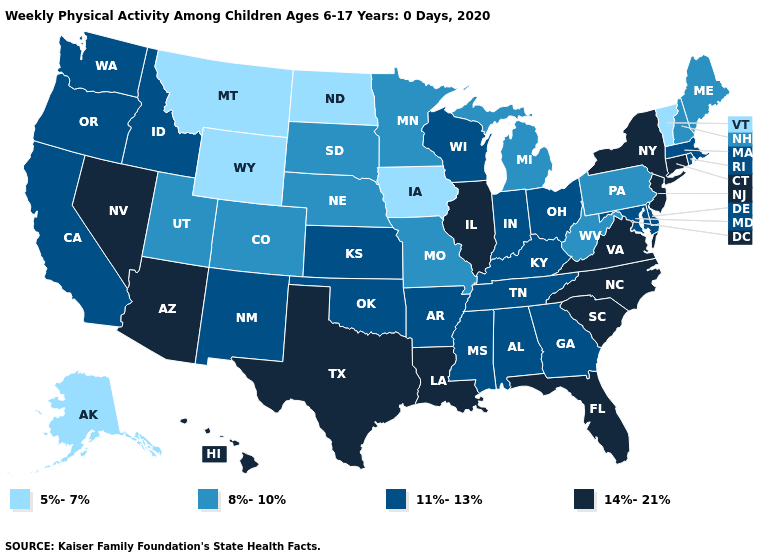Name the states that have a value in the range 14%-21%?
Write a very short answer. Arizona, Connecticut, Florida, Hawaii, Illinois, Louisiana, Nevada, New Jersey, New York, North Carolina, South Carolina, Texas, Virginia. Name the states that have a value in the range 14%-21%?
Be succinct. Arizona, Connecticut, Florida, Hawaii, Illinois, Louisiana, Nevada, New Jersey, New York, North Carolina, South Carolina, Texas, Virginia. Which states have the highest value in the USA?
Keep it brief. Arizona, Connecticut, Florida, Hawaii, Illinois, Louisiana, Nevada, New Jersey, New York, North Carolina, South Carolina, Texas, Virginia. Among the states that border Maine , which have the lowest value?
Give a very brief answer. New Hampshire. What is the lowest value in the USA?
Write a very short answer. 5%-7%. Among the states that border New Jersey , does New York have the lowest value?
Answer briefly. No. What is the lowest value in the South?
Be succinct. 8%-10%. What is the highest value in states that border Mississippi?
Short answer required. 14%-21%. What is the highest value in the MidWest ?
Short answer required. 14%-21%. What is the highest value in the MidWest ?
Keep it brief. 14%-21%. What is the value of Florida?
Write a very short answer. 14%-21%. Among the states that border Utah , does Wyoming have the lowest value?
Write a very short answer. Yes. Name the states that have a value in the range 8%-10%?
Write a very short answer. Colorado, Maine, Michigan, Minnesota, Missouri, Nebraska, New Hampshire, Pennsylvania, South Dakota, Utah, West Virginia. Does the first symbol in the legend represent the smallest category?
Short answer required. Yes. Name the states that have a value in the range 5%-7%?
Short answer required. Alaska, Iowa, Montana, North Dakota, Vermont, Wyoming. 